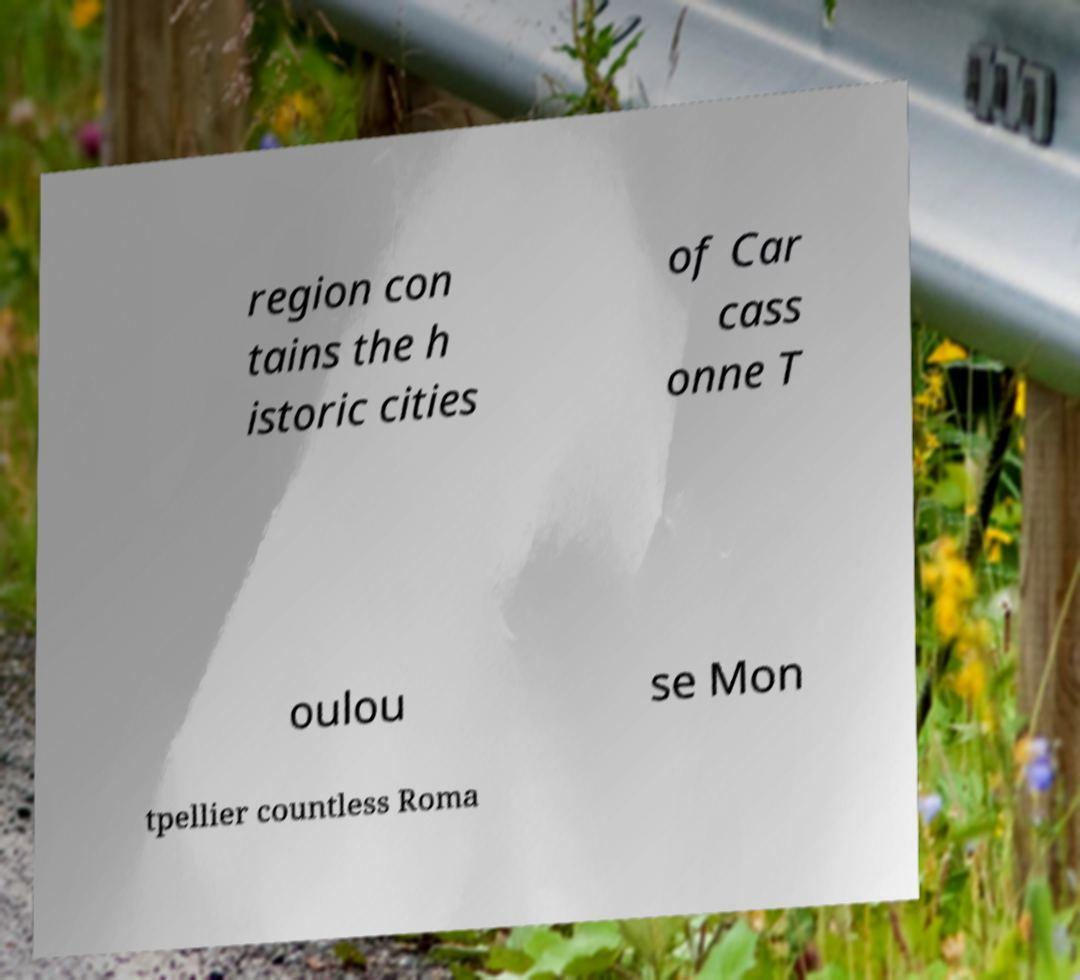Can you read and provide the text displayed in the image?This photo seems to have some interesting text. Can you extract and type it out for me? region con tains the h istoric cities of Car cass onne T oulou se Mon tpellier countless Roma 